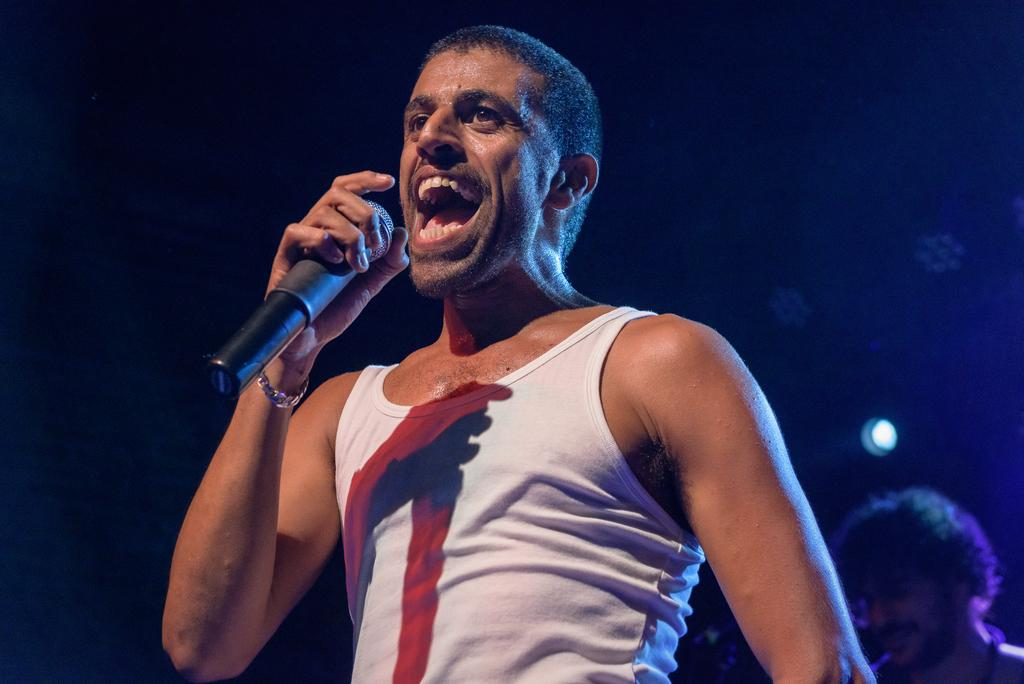What is the main action being performed by the person in the image? The person in the image is holding a microphone and singing, as indicated by their open mouth. Can you describe the second person in the image? The second person is located at the right bottom corner of the image and is smiling. What type of liquid is being poured by the giraffe in the image? There is no giraffe present in the image, and therefore no liquid being poured. 